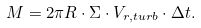<formula> <loc_0><loc_0><loc_500><loc_500>M = 2 \pi R \cdot \Sigma \cdot V _ { r , t u r b } \cdot \Delta t .</formula> 